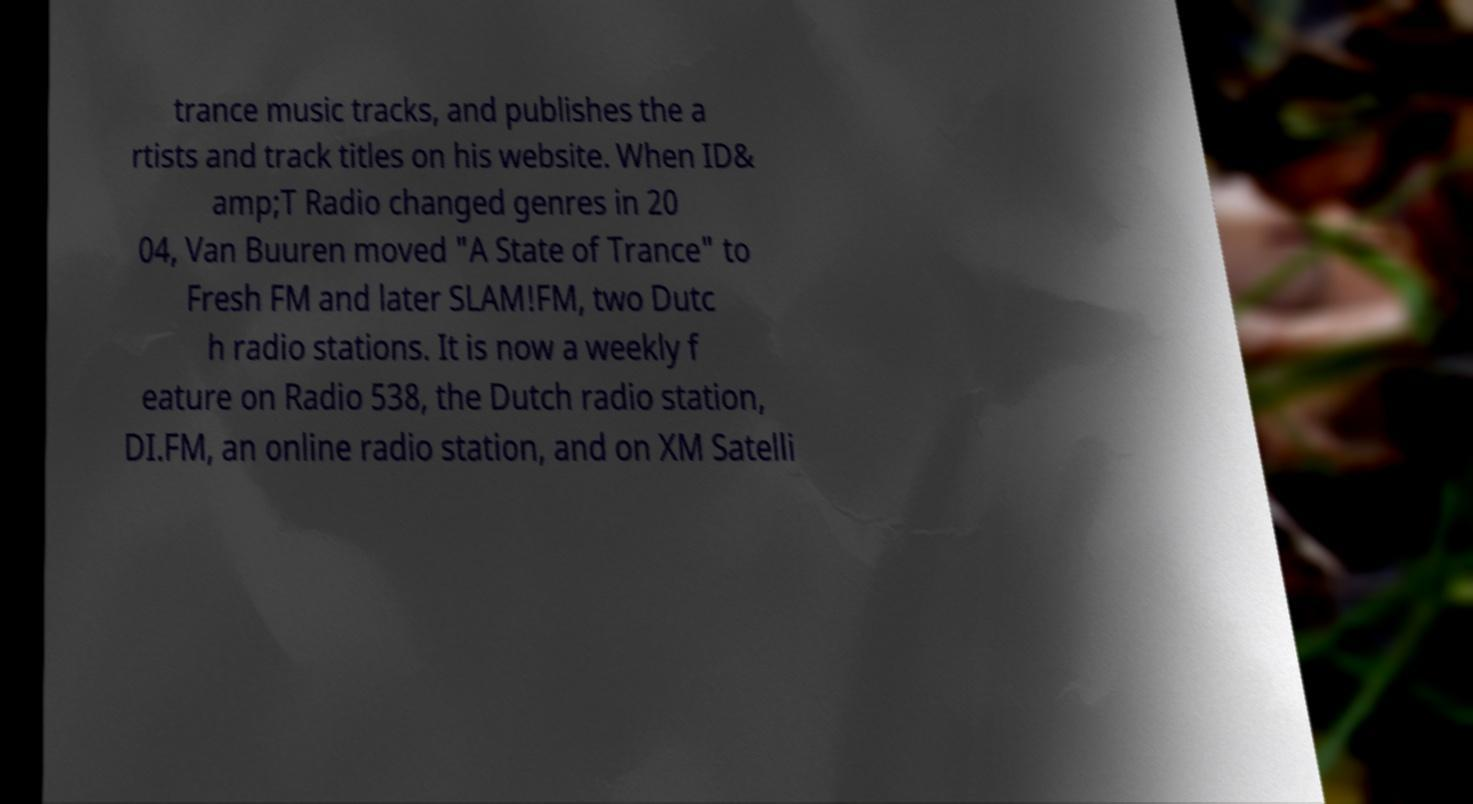Could you extract and type out the text from this image? trance music tracks, and publishes the a rtists and track titles on his website. When ID& amp;T Radio changed genres in 20 04, Van Buuren moved "A State of Trance" to Fresh FM and later SLAM!FM, two Dutc h radio stations. It is now a weekly f eature on Radio 538, the Dutch radio station, DI.FM, an online radio station, and on XM Satelli 